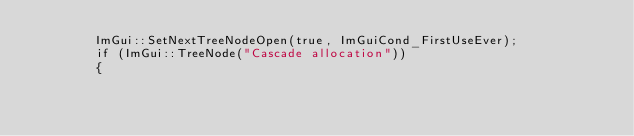Convert code to text. <code><loc_0><loc_0><loc_500><loc_500><_C++_>        ImGui::SetNextTreeNodeOpen(true, ImGuiCond_FirstUseEver);
        if (ImGui::TreeNode("Cascade allocation"))
        {</code> 